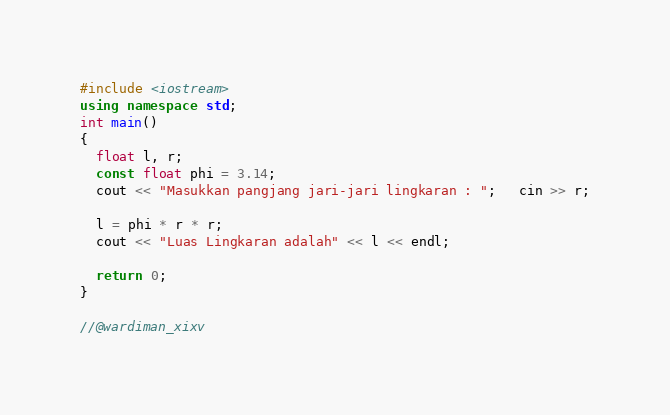Convert code to text. <code><loc_0><loc_0><loc_500><loc_500><_C++_>#include <iostream>
using namespace std;
int main()
{
  float l, r;
  const float phi = 3.14;
  cout << "Masukkan pangjang jari-jari lingkaran : ";   cin >> r;

  l = phi * r * r;
  cout << "Luas Lingkaran adalah" << l << endl;

  return 0;
}

//@wardiman_xixv</code> 